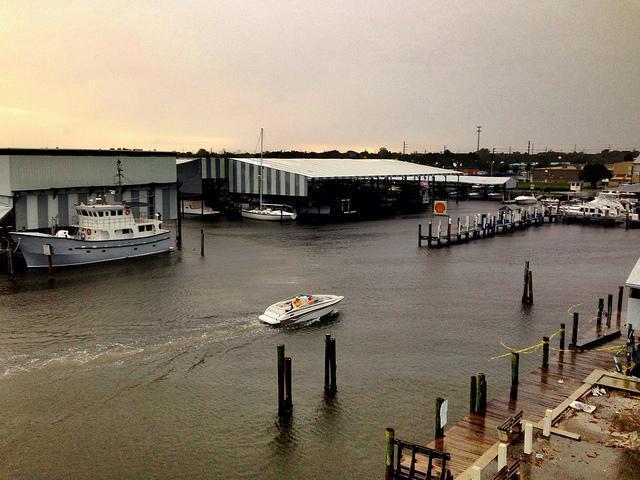How many boats are there?
Give a very brief answer. 2. 